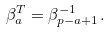<formula> <loc_0><loc_0><loc_500><loc_500>\beta _ { a } ^ { T } = \beta _ { p - a + 1 } ^ { - 1 } .</formula> 